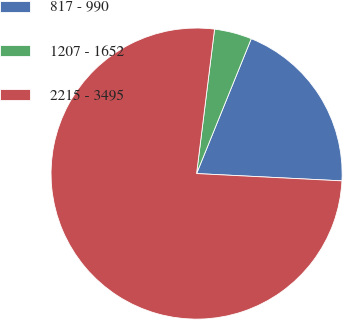Convert chart to OTSL. <chart><loc_0><loc_0><loc_500><loc_500><pie_chart><fcel>817 - 990<fcel>1207 - 1652<fcel>2215 - 3495<nl><fcel>19.67%<fcel>4.16%<fcel>76.18%<nl></chart> 